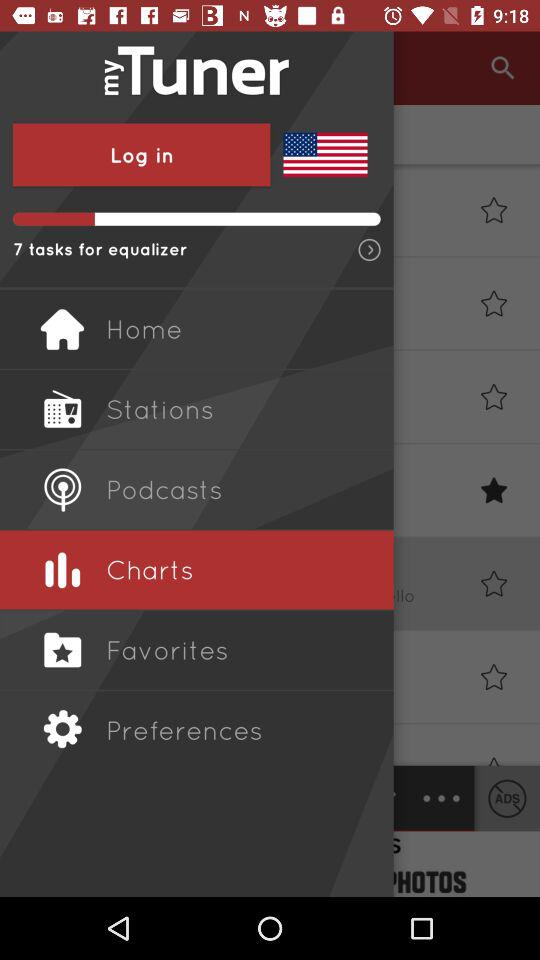Which is the selected item in the menu? The selected item is "Charts". 